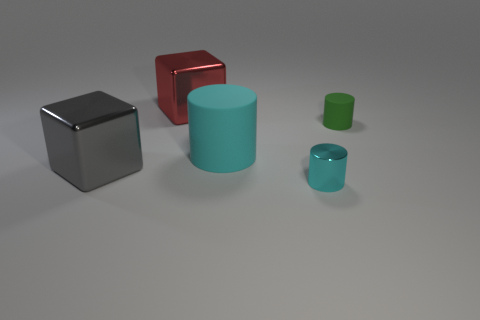There is a cyan object that is the same size as the green matte cylinder; what shape is it?
Provide a succinct answer. Cylinder. Do the tiny metal thing and the large object on the right side of the red shiny block have the same color?
Provide a succinct answer. Yes. What number of tiny metal objects are right of the metallic object that is behind the big rubber thing?
Offer a very short reply. 1. There is a metal thing that is in front of the big red metallic cube and behind the small cyan cylinder; what size is it?
Provide a succinct answer. Large. Is there a thing that has the same size as the metal cylinder?
Your answer should be compact. Yes. Are there more big objects to the right of the big gray block than big cyan cylinders in front of the cyan matte object?
Offer a very short reply. Yes. Does the tiny green thing have the same material as the tiny cylinder that is in front of the tiny rubber cylinder?
Offer a very short reply. No. There is a large object on the right side of the big object that is behind the tiny green rubber cylinder; what number of tiny green things are to the left of it?
Your response must be concise. 0. Do the big cyan object and the small green matte thing that is right of the shiny cylinder have the same shape?
Provide a succinct answer. Yes. What is the color of the object that is in front of the small matte object and behind the big gray object?
Keep it short and to the point. Cyan. 